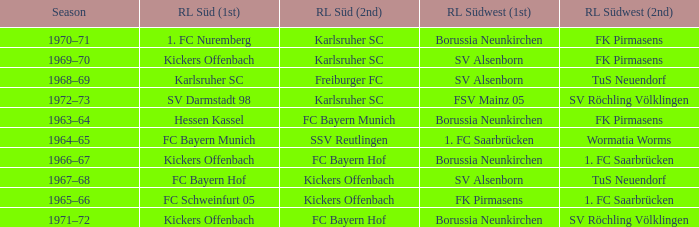Who was RL Süd (1st) when FK Pirmasens was RL Südwest (1st)? FC Schweinfurt 05. 